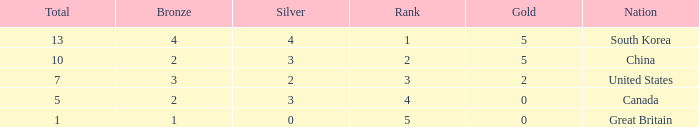What is the total number of Gold, when Silver is 2, and when Total is less than 7? 0.0. 